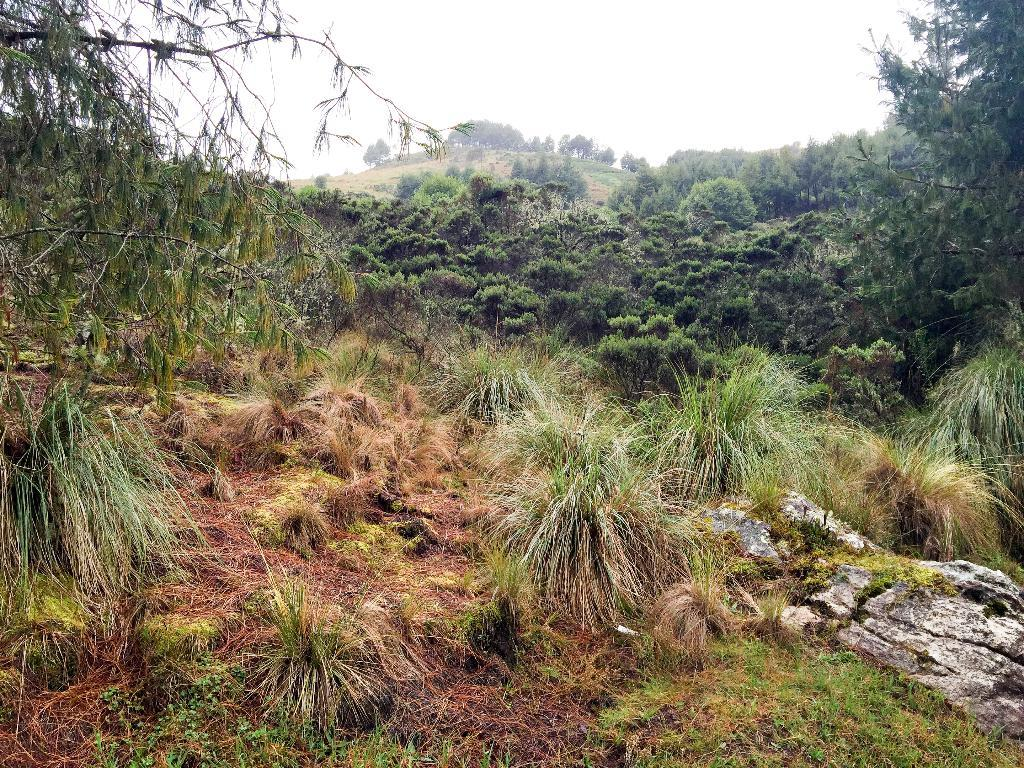What is the main subject of the image? There is a rock in the image. What type of vegetation is present at the bottom of the image? There is grass at the bottom of the image. What other natural elements can be seen in the image? There are plants in the image. What can be seen in the background of the image? There are trees and the sky visible in the background of the image. Can you see the robin's tail in the image? There is no robin present in the image, so its tail cannot be seen. 